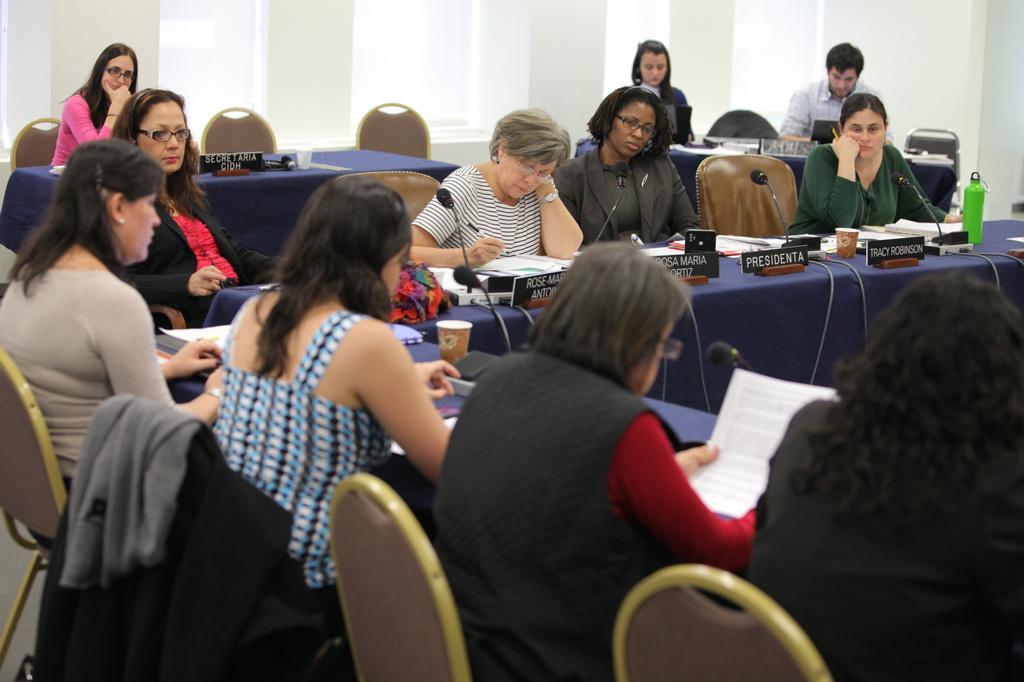Describe this image in one or two sentences. In this image there are group of persons sitting on the chairs at the left side of the image there is a woman and at the right side of the image there is man and woman and at the top of the table there is a flower bouquet and water bottle and coffee glasses and also microphones attached to the tables 